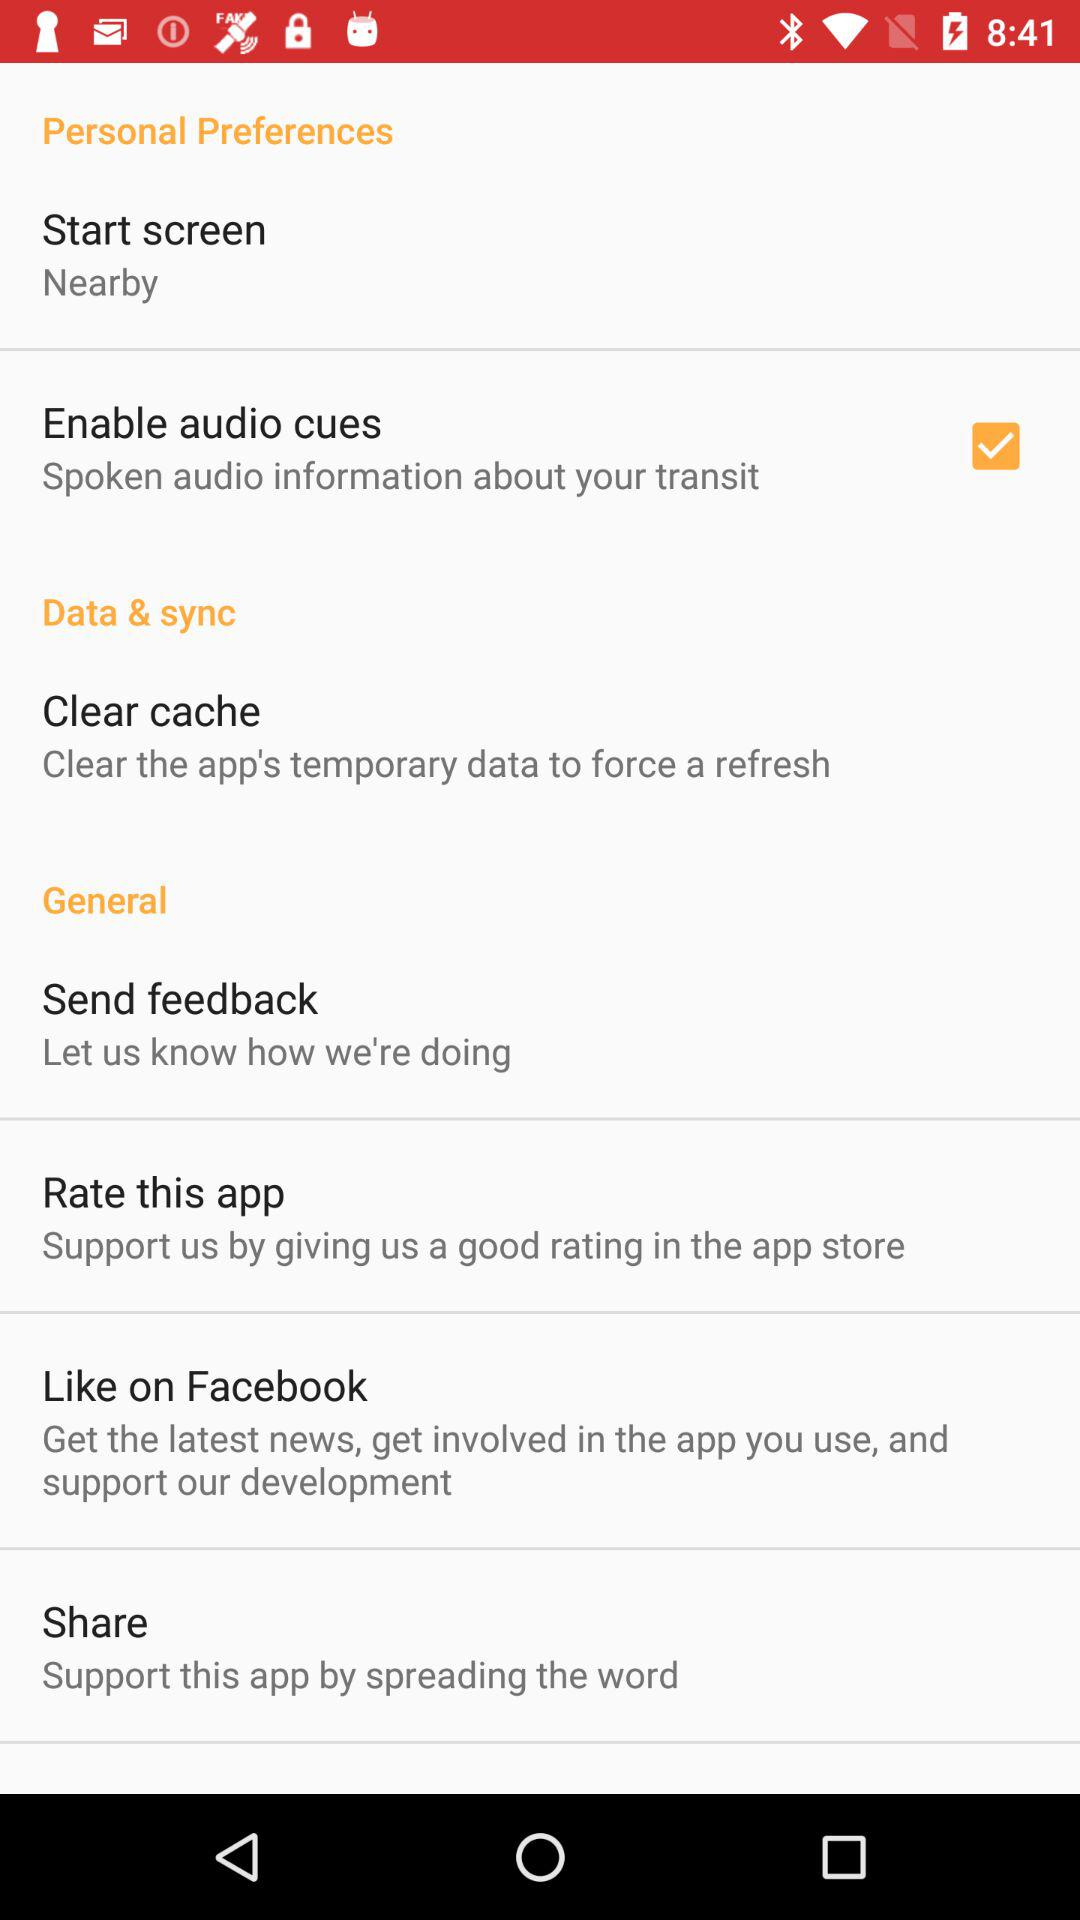What option has been selected? The selected option is "Enable audio cues". 